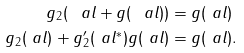Convert formula to latex. <formula><loc_0><loc_0><loc_500><loc_500>g _ { 2 } ( \ a l + g ( \ a l ) ) & = g ( \ a l ) \\ g _ { 2 } ( \ a l ) + g _ { 2 } ^ { \prime } ( \ a l ^ { * } ) g ( \ a l ) & = g ( \ a l ) .</formula> 